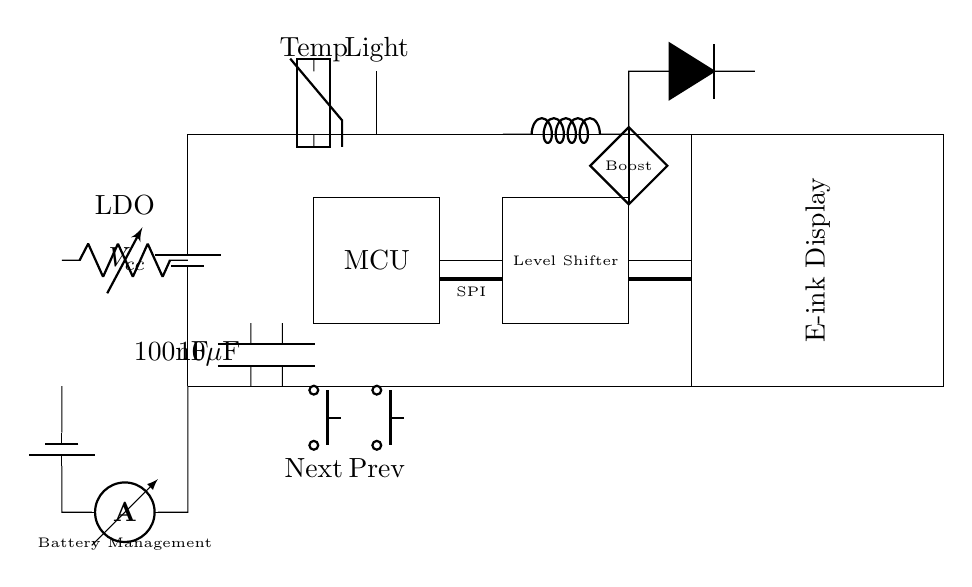What is the main power supply voltage? The main power supply voltage is indicated next to the battery, which is labeled as Vcc, but no specific numerical value is provided in the circuit diagram.
Answer: Vcc What type of sensor is used for temperature measurement? The circuit shows a component labeled as a thermistor connected to a point marked Temp, indicating that this sensor type is utilized for measuring temperature.
Answer: Thermistor What does the level shifter do in this circuit? The level shifter in the circuit translates signals from the microcontroller to levels appropriate for the e-ink display, ensuring compatibility between different voltage levels.
Answer: Signal translation How does the circuit regulate the display voltage? The circuit includes a boost converter, which is shown between the level shifter and the display, raising the voltage to a suitable level for the e-ink display, as labeled in the diagram.
Answer: Boost converter What are the decoupling capacitors' values? The circuit displays two capacitors with values marked as 100nF and 10μF. These values indicate the capacitance used for stabilizing power supply fluctuations.
Answer: 100nF, 10μF What is the purpose of the battery management component? The battery management system shown in the circuit includes an ammeter, which is used to monitor the charge and discharge currents of the battery to ensure safe operation and longevity.
Answer: Monitor charge and discharge Which connections are used for displaying data? The connections for displaying data are represented as ultra-thick lines labeled SPI, indicating that this serial protocol is used for communication between the microcontroller and the e-ink display.
Answer: SPI 